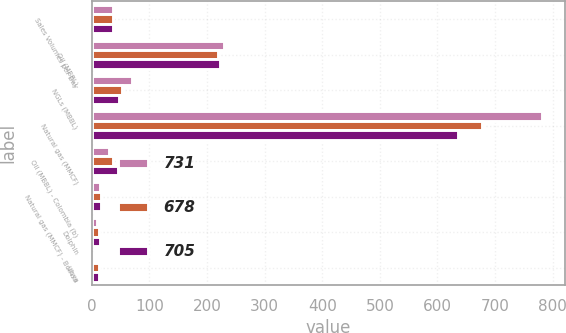Convert chart. <chart><loc_0><loc_0><loc_500><loc_500><stacked_bar_chart><ecel><fcel>Sales Volumes per Day<fcel>Oil (MBBL)<fcel>NGLs (MBBL)<fcel>Natural gas (MMCF)<fcel>Oil (MBBL) - Colombia (b)<fcel>Natural gas (MMCF) - Bolivia<fcel>Dolphin<fcel>Libya<nl><fcel>731<fcel>36<fcel>230<fcel>69<fcel>782<fcel>29<fcel>15<fcel>9<fcel>4<nl><fcel>678<fcel>36<fcel>219<fcel>52<fcel>677<fcel>36<fcel>16<fcel>12<fcel>12<nl><fcel>705<fcel>36<fcel>223<fcel>48<fcel>635<fcel>45<fcel>16<fcel>14<fcel>12<nl></chart> 